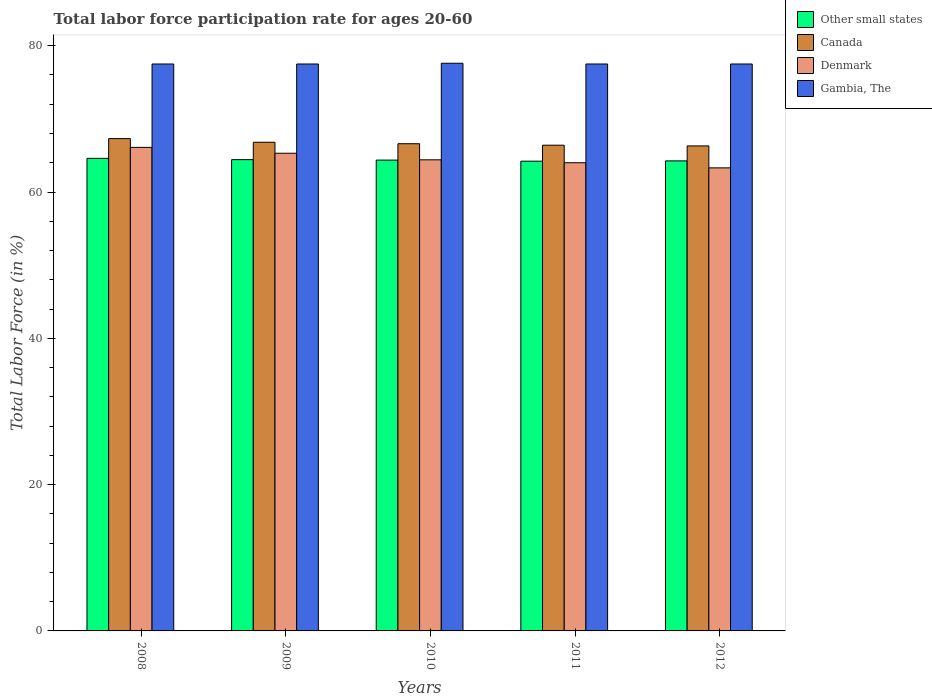How many different coloured bars are there?
Make the answer very short. 4. How many groups of bars are there?
Your response must be concise. 5. How many bars are there on the 2nd tick from the right?
Provide a succinct answer. 4. What is the label of the 2nd group of bars from the left?
Your response must be concise. 2009. What is the labor force participation rate in Other small states in 2009?
Your answer should be very brief. 64.42. Across all years, what is the maximum labor force participation rate in Other small states?
Make the answer very short. 64.6. Across all years, what is the minimum labor force participation rate in Canada?
Provide a short and direct response. 66.3. In which year was the labor force participation rate in Denmark maximum?
Make the answer very short. 2008. In which year was the labor force participation rate in Denmark minimum?
Provide a short and direct response. 2012. What is the total labor force participation rate in Canada in the graph?
Offer a very short reply. 333.4. What is the difference between the labor force participation rate in Denmark in 2009 and that in 2010?
Make the answer very short. 0.9. What is the difference between the labor force participation rate in Other small states in 2011 and the labor force participation rate in Denmark in 2009?
Your response must be concise. -1.09. What is the average labor force participation rate in Denmark per year?
Offer a very short reply. 64.62. In the year 2008, what is the difference between the labor force participation rate in Other small states and labor force participation rate in Gambia, The?
Make the answer very short. -12.9. What is the ratio of the labor force participation rate in Other small states in 2009 to that in 2011?
Make the answer very short. 1. Is the labor force participation rate in Canada in 2011 less than that in 2012?
Provide a short and direct response. No. What is the difference between the highest and the second highest labor force participation rate in Denmark?
Provide a succinct answer. 0.8. What is the difference between the highest and the lowest labor force participation rate in Denmark?
Offer a very short reply. 2.8. In how many years, is the labor force participation rate in Gambia, The greater than the average labor force participation rate in Gambia, The taken over all years?
Provide a short and direct response. 1. Is the sum of the labor force participation rate in Other small states in 2008 and 2011 greater than the maximum labor force participation rate in Canada across all years?
Give a very brief answer. Yes. What does the 1st bar from the right in 2010 represents?
Offer a very short reply. Gambia, The. How many bars are there?
Your response must be concise. 20. Are all the bars in the graph horizontal?
Provide a succinct answer. No. How many years are there in the graph?
Make the answer very short. 5. Does the graph contain any zero values?
Provide a short and direct response. No. What is the title of the graph?
Your answer should be compact. Total labor force participation rate for ages 20-60. Does "Tunisia" appear as one of the legend labels in the graph?
Give a very brief answer. No. What is the Total Labor Force (in %) in Other small states in 2008?
Offer a terse response. 64.6. What is the Total Labor Force (in %) of Canada in 2008?
Your answer should be very brief. 67.3. What is the Total Labor Force (in %) of Denmark in 2008?
Provide a short and direct response. 66.1. What is the Total Labor Force (in %) in Gambia, The in 2008?
Your answer should be very brief. 77.5. What is the Total Labor Force (in %) of Other small states in 2009?
Provide a short and direct response. 64.42. What is the Total Labor Force (in %) of Canada in 2009?
Keep it short and to the point. 66.8. What is the Total Labor Force (in %) in Denmark in 2009?
Give a very brief answer. 65.3. What is the Total Labor Force (in %) of Gambia, The in 2009?
Offer a very short reply. 77.5. What is the Total Labor Force (in %) in Other small states in 2010?
Your answer should be very brief. 64.36. What is the Total Labor Force (in %) of Canada in 2010?
Offer a very short reply. 66.6. What is the Total Labor Force (in %) of Denmark in 2010?
Keep it short and to the point. 64.4. What is the Total Labor Force (in %) of Gambia, The in 2010?
Offer a terse response. 77.6. What is the Total Labor Force (in %) in Other small states in 2011?
Ensure brevity in your answer.  64.21. What is the Total Labor Force (in %) in Canada in 2011?
Your answer should be compact. 66.4. What is the Total Labor Force (in %) in Denmark in 2011?
Offer a terse response. 64. What is the Total Labor Force (in %) in Gambia, The in 2011?
Ensure brevity in your answer.  77.5. What is the Total Labor Force (in %) of Other small states in 2012?
Your answer should be very brief. 64.25. What is the Total Labor Force (in %) of Canada in 2012?
Your response must be concise. 66.3. What is the Total Labor Force (in %) of Denmark in 2012?
Keep it short and to the point. 63.3. What is the Total Labor Force (in %) in Gambia, The in 2012?
Offer a terse response. 77.5. Across all years, what is the maximum Total Labor Force (in %) of Other small states?
Ensure brevity in your answer.  64.6. Across all years, what is the maximum Total Labor Force (in %) in Canada?
Your response must be concise. 67.3. Across all years, what is the maximum Total Labor Force (in %) in Denmark?
Offer a terse response. 66.1. Across all years, what is the maximum Total Labor Force (in %) of Gambia, The?
Ensure brevity in your answer.  77.6. Across all years, what is the minimum Total Labor Force (in %) of Other small states?
Give a very brief answer. 64.21. Across all years, what is the minimum Total Labor Force (in %) of Canada?
Your answer should be very brief. 66.3. Across all years, what is the minimum Total Labor Force (in %) in Denmark?
Offer a terse response. 63.3. Across all years, what is the minimum Total Labor Force (in %) in Gambia, The?
Provide a short and direct response. 77.5. What is the total Total Labor Force (in %) in Other small states in the graph?
Provide a short and direct response. 321.85. What is the total Total Labor Force (in %) in Canada in the graph?
Give a very brief answer. 333.4. What is the total Total Labor Force (in %) in Denmark in the graph?
Provide a succinct answer. 323.1. What is the total Total Labor Force (in %) of Gambia, The in the graph?
Give a very brief answer. 387.6. What is the difference between the Total Labor Force (in %) of Other small states in 2008 and that in 2009?
Give a very brief answer. 0.17. What is the difference between the Total Labor Force (in %) in Gambia, The in 2008 and that in 2009?
Provide a succinct answer. 0. What is the difference between the Total Labor Force (in %) of Other small states in 2008 and that in 2010?
Offer a terse response. 0.24. What is the difference between the Total Labor Force (in %) in Gambia, The in 2008 and that in 2010?
Ensure brevity in your answer.  -0.1. What is the difference between the Total Labor Force (in %) of Other small states in 2008 and that in 2011?
Your answer should be very brief. 0.38. What is the difference between the Total Labor Force (in %) of Denmark in 2008 and that in 2011?
Make the answer very short. 2.1. What is the difference between the Total Labor Force (in %) in Gambia, The in 2008 and that in 2011?
Your response must be concise. 0. What is the difference between the Total Labor Force (in %) of Other small states in 2008 and that in 2012?
Give a very brief answer. 0.34. What is the difference between the Total Labor Force (in %) of Canada in 2008 and that in 2012?
Your answer should be compact. 1. What is the difference between the Total Labor Force (in %) of Gambia, The in 2008 and that in 2012?
Give a very brief answer. 0. What is the difference between the Total Labor Force (in %) of Other small states in 2009 and that in 2010?
Offer a terse response. 0.06. What is the difference between the Total Labor Force (in %) in Canada in 2009 and that in 2010?
Your answer should be very brief. 0.2. What is the difference between the Total Labor Force (in %) in Denmark in 2009 and that in 2010?
Your response must be concise. 0.9. What is the difference between the Total Labor Force (in %) in Gambia, The in 2009 and that in 2010?
Give a very brief answer. -0.1. What is the difference between the Total Labor Force (in %) of Other small states in 2009 and that in 2011?
Give a very brief answer. 0.21. What is the difference between the Total Labor Force (in %) of Canada in 2009 and that in 2011?
Your response must be concise. 0.4. What is the difference between the Total Labor Force (in %) of Gambia, The in 2009 and that in 2011?
Offer a very short reply. 0. What is the difference between the Total Labor Force (in %) of Other small states in 2009 and that in 2012?
Provide a short and direct response. 0.17. What is the difference between the Total Labor Force (in %) of Denmark in 2009 and that in 2012?
Ensure brevity in your answer.  2. What is the difference between the Total Labor Force (in %) of Other small states in 2010 and that in 2011?
Your answer should be very brief. 0.15. What is the difference between the Total Labor Force (in %) in Denmark in 2010 and that in 2011?
Offer a terse response. 0.4. What is the difference between the Total Labor Force (in %) in Other small states in 2010 and that in 2012?
Your response must be concise. 0.11. What is the difference between the Total Labor Force (in %) in Canada in 2010 and that in 2012?
Your answer should be very brief. 0.3. What is the difference between the Total Labor Force (in %) in Denmark in 2010 and that in 2012?
Offer a very short reply. 1.1. What is the difference between the Total Labor Force (in %) of Other small states in 2011 and that in 2012?
Keep it short and to the point. -0.04. What is the difference between the Total Labor Force (in %) in Canada in 2011 and that in 2012?
Your answer should be compact. 0.1. What is the difference between the Total Labor Force (in %) of Gambia, The in 2011 and that in 2012?
Provide a succinct answer. 0. What is the difference between the Total Labor Force (in %) of Other small states in 2008 and the Total Labor Force (in %) of Canada in 2009?
Give a very brief answer. -2.2. What is the difference between the Total Labor Force (in %) of Other small states in 2008 and the Total Labor Force (in %) of Denmark in 2009?
Make the answer very short. -0.7. What is the difference between the Total Labor Force (in %) of Other small states in 2008 and the Total Labor Force (in %) of Gambia, The in 2009?
Provide a short and direct response. -12.9. What is the difference between the Total Labor Force (in %) in Other small states in 2008 and the Total Labor Force (in %) in Canada in 2010?
Make the answer very short. -2. What is the difference between the Total Labor Force (in %) of Other small states in 2008 and the Total Labor Force (in %) of Denmark in 2010?
Ensure brevity in your answer.  0.2. What is the difference between the Total Labor Force (in %) in Other small states in 2008 and the Total Labor Force (in %) in Gambia, The in 2010?
Keep it short and to the point. -13. What is the difference between the Total Labor Force (in %) of Canada in 2008 and the Total Labor Force (in %) of Denmark in 2010?
Your answer should be very brief. 2.9. What is the difference between the Total Labor Force (in %) of Canada in 2008 and the Total Labor Force (in %) of Gambia, The in 2010?
Provide a short and direct response. -10.3. What is the difference between the Total Labor Force (in %) in Other small states in 2008 and the Total Labor Force (in %) in Canada in 2011?
Provide a succinct answer. -1.8. What is the difference between the Total Labor Force (in %) in Other small states in 2008 and the Total Labor Force (in %) in Denmark in 2011?
Your answer should be very brief. 0.6. What is the difference between the Total Labor Force (in %) in Other small states in 2008 and the Total Labor Force (in %) in Gambia, The in 2011?
Your answer should be compact. -12.9. What is the difference between the Total Labor Force (in %) of Canada in 2008 and the Total Labor Force (in %) of Denmark in 2011?
Ensure brevity in your answer.  3.3. What is the difference between the Total Labor Force (in %) in Other small states in 2008 and the Total Labor Force (in %) in Canada in 2012?
Your answer should be very brief. -1.7. What is the difference between the Total Labor Force (in %) in Other small states in 2008 and the Total Labor Force (in %) in Denmark in 2012?
Give a very brief answer. 1.3. What is the difference between the Total Labor Force (in %) of Other small states in 2008 and the Total Labor Force (in %) of Gambia, The in 2012?
Your answer should be compact. -12.9. What is the difference between the Total Labor Force (in %) of Canada in 2008 and the Total Labor Force (in %) of Gambia, The in 2012?
Your answer should be compact. -10.2. What is the difference between the Total Labor Force (in %) in Denmark in 2008 and the Total Labor Force (in %) in Gambia, The in 2012?
Offer a very short reply. -11.4. What is the difference between the Total Labor Force (in %) in Other small states in 2009 and the Total Labor Force (in %) in Canada in 2010?
Make the answer very short. -2.18. What is the difference between the Total Labor Force (in %) of Other small states in 2009 and the Total Labor Force (in %) of Denmark in 2010?
Offer a very short reply. 0.02. What is the difference between the Total Labor Force (in %) in Other small states in 2009 and the Total Labor Force (in %) in Gambia, The in 2010?
Make the answer very short. -13.18. What is the difference between the Total Labor Force (in %) of Other small states in 2009 and the Total Labor Force (in %) of Canada in 2011?
Provide a succinct answer. -1.98. What is the difference between the Total Labor Force (in %) of Other small states in 2009 and the Total Labor Force (in %) of Denmark in 2011?
Offer a terse response. 0.42. What is the difference between the Total Labor Force (in %) of Other small states in 2009 and the Total Labor Force (in %) of Gambia, The in 2011?
Make the answer very short. -13.08. What is the difference between the Total Labor Force (in %) in Canada in 2009 and the Total Labor Force (in %) in Denmark in 2011?
Your answer should be very brief. 2.8. What is the difference between the Total Labor Force (in %) in Other small states in 2009 and the Total Labor Force (in %) in Canada in 2012?
Give a very brief answer. -1.88. What is the difference between the Total Labor Force (in %) in Other small states in 2009 and the Total Labor Force (in %) in Denmark in 2012?
Your response must be concise. 1.12. What is the difference between the Total Labor Force (in %) in Other small states in 2009 and the Total Labor Force (in %) in Gambia, The in 2012?
Your answer should be compact. -13.08. What is the difference between the Total Labor Force (in %) in Canada in 2009 and the Total Labor Force (in %) in Denmark in 2012?
Give a very brief answer. 3.5. What is the difference between the Total Labor Force (in %) in Canada in 2009 and the Total Labor Force (in %) in Gambia, The in 2012?
Ensure brevity in your answer.  -10.7. What is the difference between the Total Labor Force (in %) of Other small states in 2010 and the Total Labor Force (in %) of Canada in 2011?
Your answer should be compact. -2.04. What is the difference between the Total Labor Force (in %) of Other small states in 2010 and the Total Labor Force (in %) of Denmark in 2011?
Provide a succinct answer. 0.36. What is the difference between the Total Labor Force (in %) in Other small states in 2010 and the Total Labor Force (in %) in Gambia, The in 2011?
Keep it short and to the point. -13.14. What is the difference between the Total Labor Force (in %) of Canada in 2010 and the Total Labor Force (in %) of Gambia, The in 2011?
Offer a terse response. -10.9. What is the difference between the Total Labor Force (in %) in Other small states in 2010 and the Total Labor Force (in %) in Canada in 2012?
Ensure brevity in your answer.  -1.94. What is the difference between the Total Labor Force (in %) of Other small states in 2010 and the Total Labor Force (in %) of Denmark in 2012?
Make the answer very short. 1.06. What is the difference between the Total Labor Force (in %) of Other small states in 2010 and the Total Labor Force (in %) of Gambia, The in 2012?
Make the answer very short. -13.14. What is the difference between the Total Labor Force (in %) of Other small states in 2011 and the Total Labor Force (in %) of Canada in 2012?
Ensure brevity in your answer.  -2.09. What is the difference between the Total Labor Force (in %) in Other small states in 2011 and the Total Labor Force (in %) in Denmark in 2012?
Your response must be concise. 0.91. What is the difference between the Total Labor Force (in %) of Other small states in 2011 and the Total Labor Force (in %) of Gambia, The in 2012?
Your answer should be very brief. -13.29. What is the average Total Labor Force (in %) of Other small states per year?
Your answer should be compact. 64.37. What is the average Total Labor Force (in %) of Canada per year?
Offer a very short reply. 66.68. What is the average Total Labor Force (in %) in Denmark per year?
Give a very brief answer. 64.62. What is the average Total Labor Force (in %) in Gambia, The per year?
Make the answer very short. 77.52. In the year 2008, what is the difference between the Total Labor Force (in %) in Other small states and Total Labor Force (in %) in Canada?
Offer a very short reply. -2.7. In the year 2008, what is the difference between the Total Labor Force (in %) in Other small states and Total Labor Force (in %) in Denmark?
Your answer should be very brief. -1.5. In the year 2008, what is the difference between the Total Labor Force (in %) of Other small states and Total Labor Force (in %) of Gambia, The?
Give a very brief answer. -12.9. In the year 2008, what is the difference between the Total Labor Force (in %) in Canada and Total Labor Force (in %) in Gambia, The?
Provide a short and direct response. -10.2. In the year 2008, what is the difference between the Total Labor Force (in %) in Denmark and Total Labor Force (in %) in Gambia, The?
Ensure brevity in your answer.  -11.4. In the year 2009, what is the difference between the Total Labor Force (in %) in Other small states and Total Labor Force (in %) in Canada?
Provide a succinct answer. -2.38. In the year 2009, what is the difference between the Total Labor Force (in %) in Other small states and Total Labor Force (in %) in Denmark?
Offer a terse response. -0.88. In the year 2009, what is the difference between the Total Labor Force (in %) of Other small states and Total Labor Force (in %) of Gambia, The?
Make the answer very short. -13.08. In the year 2009, what is the difference between the Total Labor Force (in %) of Canada and Total Labor Force (in %) of Gambia, The?
Provide a succinct answer. -10.7. In the year 2009, what is the difference between the Total Labor Force (in %) of Denmark and Total Labor Force (in %) of Gambia, The?
Your answer should be very brief. -12.2. In the year 2010, what is the difference between the Total Labor Force (in %) of Other small states and Total Labor Force (in %) of Canada?
Provide a short and direct response. -2.24. In the year 2010, what is the difference between the Total Labor Force (in %) of Other small states and Total Labor Force (in %) of Denmark?
Provide a succinct answer. -0.04. In the year 2010, what is the difference between the Total Labor Force (in %) in Other small states and Total Labor Force (in %) in Gambia, The?
Offer a terse response. -13.24. In the year 2010, what is the difference between the Total Labor Force (in %) of Canada and Total Labor Force (in %) of Gambia, The?
Provide a succinct answer. -11. In the year 2010, what is the difference between the Total Labor Force (in %) of Denmark and Total Labor Force (in %) of Gambia, The?
Your answer should be compact. -13.2. In the year 2011, what is the difference between the Total Labor Force (in %) in Other small states and Total Labor Force (in %) in Canada?
Make the answer very short. -2.19. In the year 2011, what is the difference between the Total Labor Force (in %) in Other small states and Total Labor Force (in %) in Denmark?
Give a very brief answer. 0.21. In the year 2011, what is the difference between the Total Labor Force (in %) in Other small states and Total Labor Force (in %) in Gambia, The?
Provide a succinct answer. -13.29. In the year 2011, what is the difference between the Total Labor Force (in %) of Canada and Total Labor Force (in %) of Gambia, The?
Offer a very short reply. -11.1. In the year 2011, what is the difference between the Total Labor Force (in %) in Denmark and Total Labor Force (in %) in Gambia, The?
Offer a very short reply. -13.5. In the year 2012, what is the difference between the Total Labor Force (in %) in Other small states and Total Labor Force (in %) in Canada?
Ensure brevity in your answer.  -2.05. In the year 2012, what is the difference between the Total Labor Force (in %) of Other small states and Total Labor Force (in %) of Denmark?
Provide a succinct answer. 0.95. In the year 2012, what is the difference between the Total Labor Force (in %) of Other small states and Total Labor Force (in %) of Gambia, The?
Provide a short and direct response. -13.25. In the year 2012, what is the difference between the Total Labor Force (in %) in Denmark and Total Labor Force (in %) in Gambia, The?
Provide a succinct answer. -14.2. What is the ratio of the Total Labor Force (in %) in Canada in 2008 to that in 2009?
Make the answer very short. 1.01. What is the ratio of the Total Labor Force (in %) in Denmark in 2008 to that in 2009?
Offer a very short reply. 1.01. What is the ratio of the Total Labor Force (in %) in Gambia, The in 2008 to that in 2009?
Keep it short and to the point. 1. What is the ratio of the Total Labor Force (in %) in Other small states in 2008 to that in 2010?
Your answer should be compact. 1. What is the ratio of the Total Labor Force (in %) in Canada in 2008 to that in 2010?
Offer a very short reply. 1.01. What is the ratio of the Total Labor Force (in %) in Denmark in 2008 to that in 2010?
Ensure brevity in your answer.  1.03. What is the ratio of the Total Labor Force (in %) in Gambia, The in 2008 to that in 2010?
Make the answer very short. 1. What is the ratio of the Total Labor Force (in %) of Other small states in 2008 to that in 2011?
Keep it short and to the point. 1.01. What is the ratio of the Total Labor Force (in %) of Canada in 2008 to that in 2011?
Provide a succinct answer. 1.01. What is the ratio of the Total Labor Force (in %) of Denmark in 2008 to that in 2011?
Your response must be concise. 1.03. What is the ratio of the Total Labor Force (in %) in Canada in 2008 to that in 2012?
Your response must be concise. 1.02. What is the ratio of the Total Labor Force (in %) of Denmark in 2008 to that in 2012?
Your response must be concise. 1.04. What is the ratio of the Total Labor Force (in %) in Gambia, The in 2009 to that in 2010?
Your response must be concise. 1. What is the ratio of the Total Labor Force (in %) of Canada in 2009 to that in 2011?
Give a very brief answer. 1.01. What is the ratio of the Total Labor Force (in %) in Denmark in 2009 to that in 2011?
Offer a very short reply. 1.02. What is the ratio of the Total Labor Force (in %) in Gambia, The in 2009 to that in 2011?
Offer a very short reply. 1. What is the ratio of the Total Labor Force (in %) in Canada in 2009 to that in 2012?
Offer a terse response. 1.01. What is the ratio of the Total Labor Force (in %) of Denmark in 2009 to that in 2012?
Give a very brief answer. 1.03. What is the ratio of the Total Labor Force (in %) in Gambia, The in 2010 to that in 2011?
Ensure brevity in your answer.  1. What is the ratio of the Total Labor Force (in %) in Denmark in 2010 to that in 2012?
Give a very brief answer. 1.02. What is the ratio of the Total Labor Force (in %) in Gambia, The in 2010 to that in 2012?
Make the answer very short. 1. What is the ratio of the Total Labor Force (in %) of Other small states in 2011 to that in 2012?
Offer a very short reply. 1. What is the ratio of the Total Labor Force (in %) in Denmark in 2011 to that in 2012?
Your response must be concise. 1.01. What is the ratio of the Total Labor Force (in %) of Gambia, The in 2011 to that in 2012?
Offer a very short reply. 1. What is the difference between the highest and the second highest Total Labor Force (in %) in Other small states?
Provide a short and direct response. 0.17. What is the difference between the highest and the second highest Total Labor Force (in %) of Gambia, The?
Your response must be concise. 0.1. What is the difference between the highest and the lowest Total Labor Force (in %) of Other small states?
Make the answer very short. 0.38. What is the difference between the highest and the lowest Total Labor Force (in %) of Gambia, The?
Your answer should be compact. 0.1. 